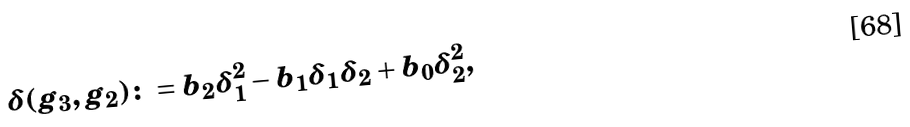Convert formula to latex. <formula><loc_0><loc_0><loc_500><loc_500>\delta ( g _ { 3 } , g _ { 2 } ) \colon = b _ { 2 } \delta _ { 1 } ^ { 2 } - b _ { 1 } \delta _ { 1 } \delta _ { 2 } + b _ { 0 } \delta _ { 2 } ^ { 2 } ,</formula> 